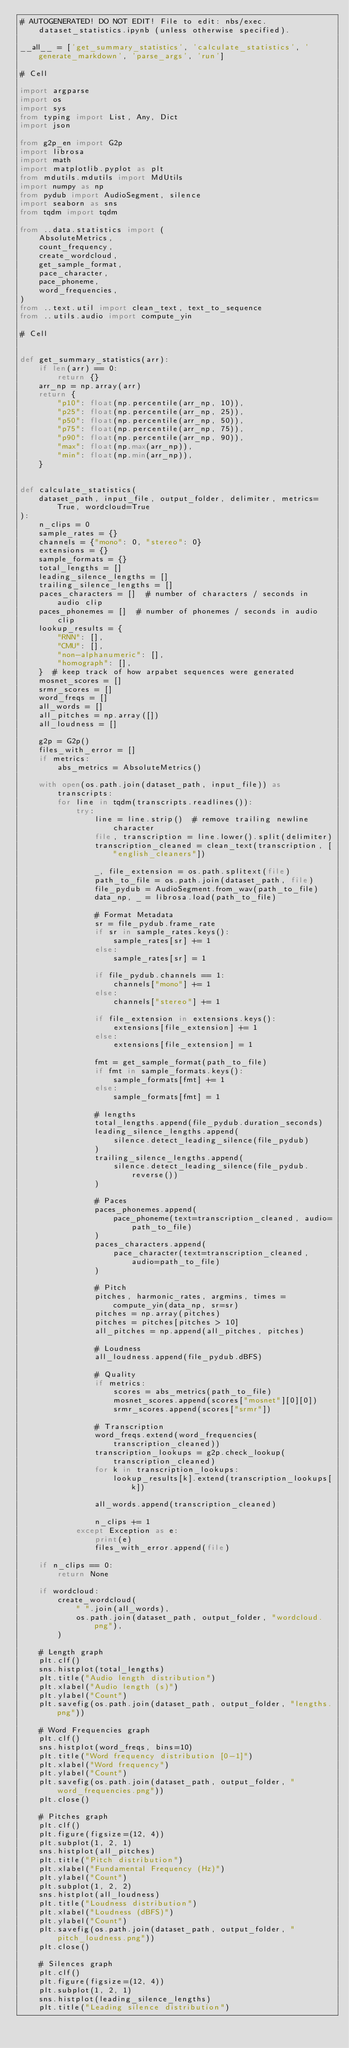Convert code to text. <code><loc_0><loc_0><loc_500><loc_500><_Python_># AUTOGENERATED! DO NOT EDIT! File to edit: nbs/exec.dataset_statistics.ipynb (unless otherwise specified).

__all__ = ['get_summary_statistics', 'calculate_statistics', 'generate_markdown', 'parse_args', 'run']

# Cell

import argparse
import os
import sys
from typing import List, Any, Dict
import json

from g2p_en import G2p
import librosa
import math
import matplotlib.pyplot as plt
from mdutils.mdutils import MdUtils
import numpy as np
from pydub import AudioSegment, silence
import seaborn as sns
from tqdm import tqdm

from ..data.statistics import (
    AbsoluteMetrics,
    count_frequency,
    create_wordcloud,
    get_sample_format,
    pace_character,
    pace_phoneme,
    word_frequencies,
)
from ..text.util import clean_text, text_to_sequence
from ..utils.audio import compute_yin

# Cell


def get_summary_statistics(arr):
    if len(arr) == 0:
        return {}
    arr_np = np.array(arr)
    return {
        "p10": float(np.percentile(arr_np, 10)),
        "p25": float(np.percentile(arr_np, 25)),
        "p50": float(np.percentile(arr_np, 50)),
        "p75": float(np.percentile(arr_np, 75)),
        "p90": float(np.percentile(arr_np, 90)),
        "max": float(np.max(arr_np)),
        "min": float(np.min(arr_np)),
    }


def calculate_statistics(
    dataset_path, input_file, output_folder, delimiter, metrics=True, wordcloud=True
):
    n_clips = 0
    sample_rates = {}
    channels = {"mono": 0, "stereo": 0}
    extensions = {}
    sample_formats = {}
    total_lengths = []
    leading_silence_lengths = []
    trailing_silence_lengths = []
    paces_characters = []  # number of characters / seconds in audio clip
    paces_phonemes = []  # number of phonemes / seconds in audio clip
    lookup_results = {
        "RNN": [],
        "CMU": [],
        "non-alphanumeric": [],
        "homograph": [],
    }  # keep track of how arpabet sequences were generated
    mosnet_scores = []
    srmr_scores = []
    word_freqs = []
    all_words = []
    all_pitches = np.array([])
    all_loudness = []

    g2p = G2p()
    files_with_error = []
    if metrics:
        abs_metrics = AbsoluteMetrics()

    with open(os.path.join(dataset_path, input_file)) as transcripts:
        for line in tqdm(transcripts.readlines()):
            try:
                line = line.strip()  # remove trailing newline character
                file, transcription = line.lower().split(delimiter)
                transcription_cleaned = clean_text(transcription, ["english_cleaners"])

                _, file_extension = os.path.splitext(file)
                path_to_file = os.path.join(dataset_path, file)
                file_pydub = AudioSegment.from_wav(path_to_file)
                data_np, _ = librosa.load(path_to_file)

                # Format Metadata
                sr = file_pydub.frame_rate
                if sr in sample_rates.keys():
                    sample_rates[sr] += 1
                else:
                    sample_rates[sr] = 1

                if file_pydub.channels == 1:
                    channels["mono"] += 1
                else:
                    channels["stereo"] += 1

                if file_extension in extensions.keys():
                    extensions[file_extension] += 1
                else:
                    extensions[file_extension] = 1

                fmt = get_sample_format(path_to_file)
                if fmt in sample_formats.keys():
                    sample_formats[fmt] += 1
                else:
                    sample_formats[fmt] = 1

                # lengths
                total_lengths.append(file_pydub.duration_seconds)
                leading_silence_lengths.append(
                    silence.detect_leading_silence(file_pydub)
                )
                trailing_silence_lengths.append(
                    silence.detect_leading_silence(file_pydub.reverse())
                )

                # Paces
                paces_phonemes.append(
                    pace_phoneme(text=transcription_cleaned, audio=path_to_file)
                )
                paces_characters.append(
                    pace_character(text=transcription_cleaned, audio=path_to_file)
                )

                # Pitch
                pitches, harmonic_rates, argmins, times = compute_yin(data_np, sr=sr)
                pitches = np.array(pitches)
                pitches = pitches[pitches > 10]
                all_pitches = np.append(all_pitches, pitches)

                # Loudness
                all_loudness.append(file_pydub.dBFS)

                # Quality
                if metrics:
                    scores = abs_metrics(path_to_file)
                    mosnet_scores.append(scores["mosnet"][0][0])
                    srmr_scores.append(scores["srmr"])

                # Transcription
                word_freqs.extend(word_frequencies(transcription_cleaned))
                transcription_lookups = g2p.check_lookup(transcription_cleaned)
                for k in transcription_lookups:
                    lookup_results[k].extend(transcription_lookups[k])

                all_words.append(transcription_cleaned)

                n_clips += 1
            except Exception as e:
                print(e)
                files_with_error.append(file)

    if n_clips == 0:
        return None

    if wordcloud:
        create_wordcloud(
            " ".join(all_words),
            os.path.join(dataset_path, output_folder, "wordcloud.png"),
        )

    # Length graph
    plt.clf()
    sns.histplot(total_lengths)
    plt.title("Audio length distribution")
    plt.xlabel("Audio length (s)")
    plt.ylabel("Count")
    plt.savefig(os.path.join(dataset_path, output_folder, "lengths.png"))

    # Word Frequencies graph
    plt.clf()
    sns.histplot(word_freqs, bins=10)
    plt.title("Word frequency distribution [0-1]")
    plt.xlabel("Word frequency")
    plt.ylabel("Count")
    plt.savefig(os.path.join(dataset_path, output_folder, "word_frequencies.png"))
    plt.close()

    # Pitches graph
    plt.clf()
    plt.figure(figsize=(12, 4))
    plt.subplot(1, 2, 1)
    sns.histplot(all_pitches)
    plt.title("Pitch distribution")
    plt.xlabel("Fundamental Frequency (Hz)")
    plt.ylabel("Count")
    plt.subplot(1, 2, 2)
    sns.histplot(all_loudness)
    plt.title("Loudness distribution")
    plt.xlabel("Loudness (dBFS)")
    plt.ylabel("Count")
    plt.savefig(os.path.join(dataset_path, output_folder, "pitch_loudness.png"))
    plt.close()

    # Silences graph
    plt.clf()
    plt.figure(figsize=(12, 4))
    plt.subplot(1, 2, 1)
    sns.histplot(leading_silence_lengths)
    plt.title("Leading silence distribution")</code> 